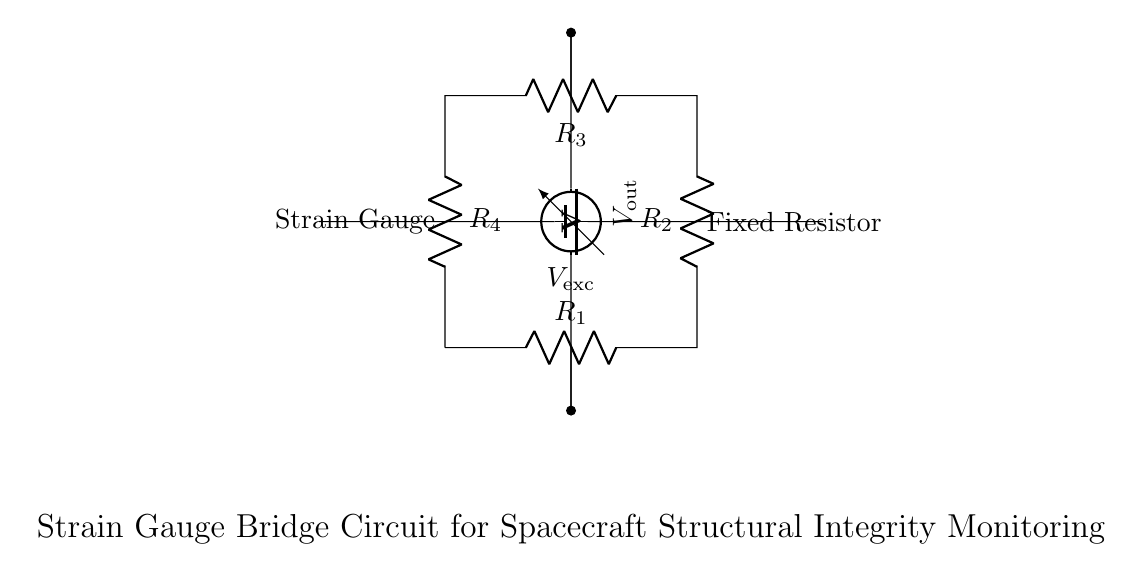What type of circuit is this? This circuit is a bridge circuit, specifically a strain gauge bridge, which is used for measuring small changes in resistance due to strain.
Answer: Bridge circuit What does the voltage source provide? The voltage source provides excitation voltage to the bridge circuit. In this case, it's denoted as V_ex.
Answer: V_ex How many resistors are in the circuit? There are four resistors in the circuit, labeled R1, R2, R3, and R4, arranged in a bridge configuration.
Answer: Four What is measured at the output of the circuit? The output of the circuit measures the potential difference caused by the imbalance in the bridge, represented by V_out.
Answer: V_out What is the purpose of the strain gauge? The strain gauge serves to detect changes in strain on the spacecraft component it is attached to, which can be translated into a change in resistance.
Answer: To detect strain How does the bridge configuration help in measurements? The bridge configuration allows for high sensitivity in detecting small changes in resistance that occur due to strain, by comparing changes between two halves of the circuit.
Answer: High sensitivity 